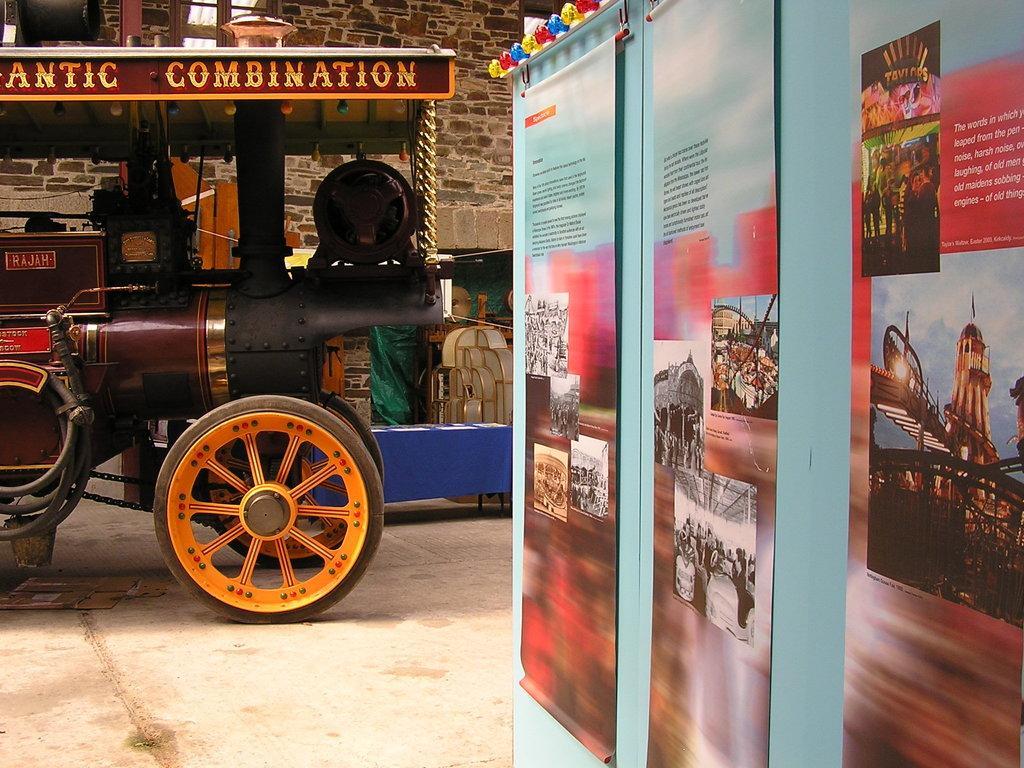In one or two sentences, can you explain what this image depicts? In this picture there is a vehicle on the left side of the image. At the back there's a wall. On the right side of the image there are posters on the wall and there are pictures of group of people and building and sky and clouds on the posters and there is a text on the posters. 